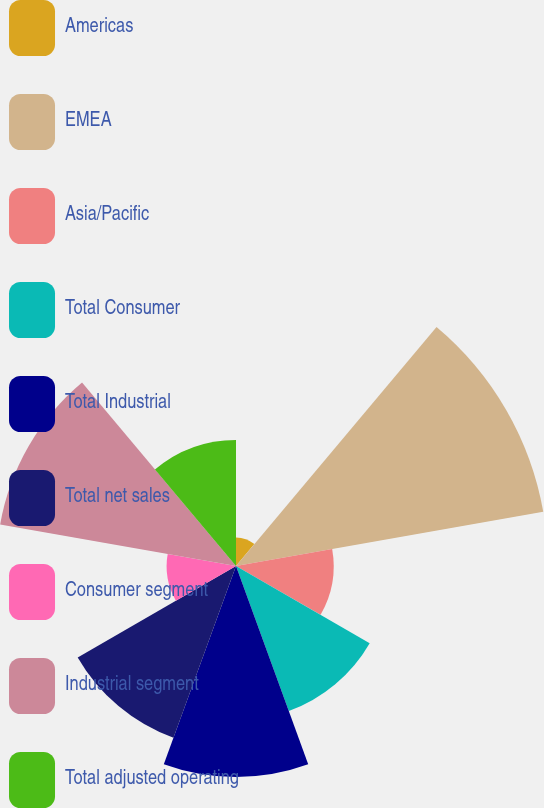<chart> <loc_0><loc_0><loc_500><loc_500><pie_chart><fcel>Americas<fcel>EMEA<fcel>Asia/Pacific<fcel>Total Consumer<fcel>Total Industrial<fcel>Total net sales<fcel>Consumer segment<fcel>Industrial segment<fcel>Total adjusted operating<nl><fcel>2.01%<fcel>21.95%<fcel>6.87%<fcel>10.86%<fcel>14.85%<fcel>12.86%<fcel>4.88%<fcel>16.85%<fcel>8.87%<nl></chart> 